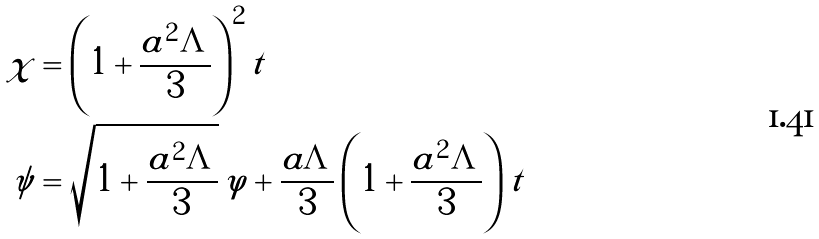<formula> <loc_0><loc_0><loc_500><loc_500>\chi & = \left ( 1 + \frac { a ^ { 2 } \Lambda } { 3 } \right ) ^ { 2 } t \\ \psi & = \sqrt { 1 + \frac { a ^ { 2 } \Lambda } { 3 } } \, \varphi + \frac { a \Lambda } { 3 } \left ( 1 + \frac { a ^ { 2 } \Lambda } { 3 } \right ) t</formula> 